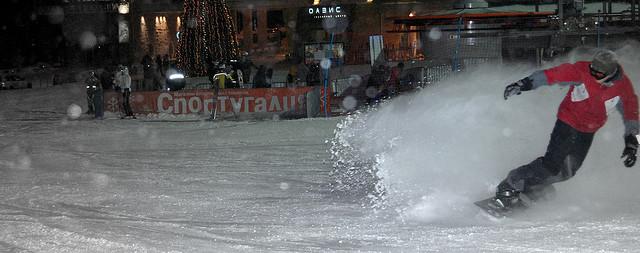What color is the man's jacket on the right?
Answer briefly. Red. Does this look recreational or competitive?
Quick response, please. Competitive. What is the person riding on?
Short answer required. Snowboard. What is piled up on the left?
Answer briefly. Snow. 